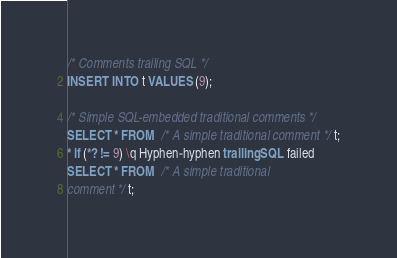Convert code to text. <code><loc_0><loc_0><loc_500><loc_500><_SQL_>
/* Comments trailing SQL */
INSERT INTO t VALUES (9);

/* Simple SQL-embedded traditional comments */
SELECT * FROM  /* A simple traditional comment */ t;
* if (*? != 9) \q Hyphen-hyphen trailing SQL failed
SELECT * FROM  /* A simple traditional
comment */ t;</code> 